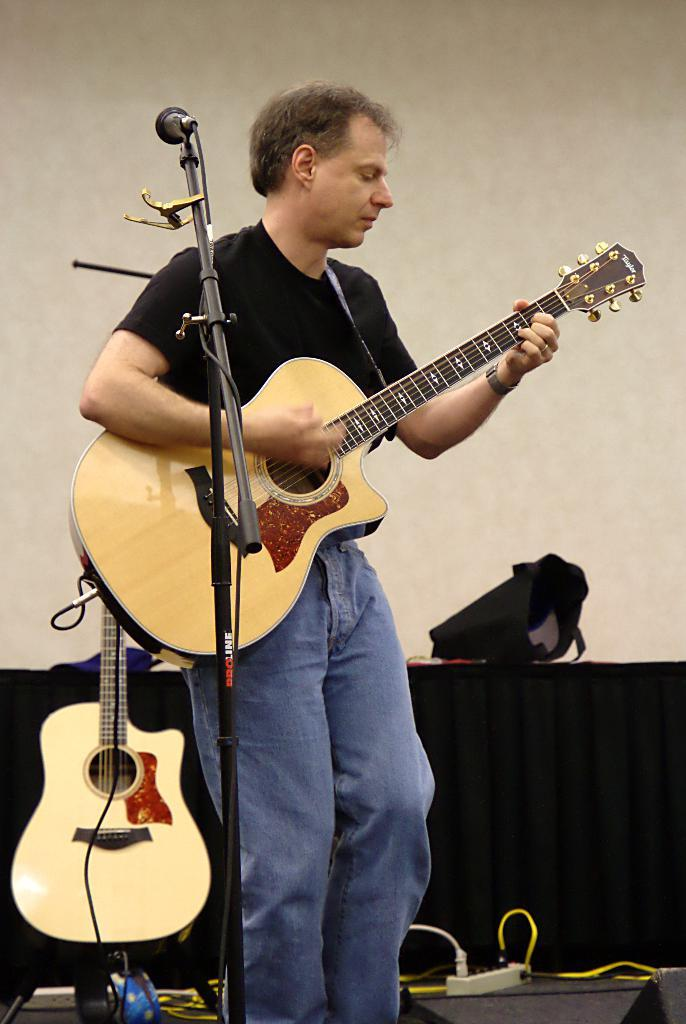What is the main subject of the image? There is a person in the image. What is the person doing in the image? The person is standing in front of a microphone and playing a guitar. What type of magic trick is the person performing with the bike in the image? There is no bike present in the image, and the person is not performing any magic tricks. 